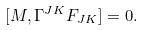Convert formula to latex. <formula><loc_0><loc_0><loc_500><loc_500>[ M , \Gamma ^ { J K } F _ { J K } ] = 0 .</formula> 